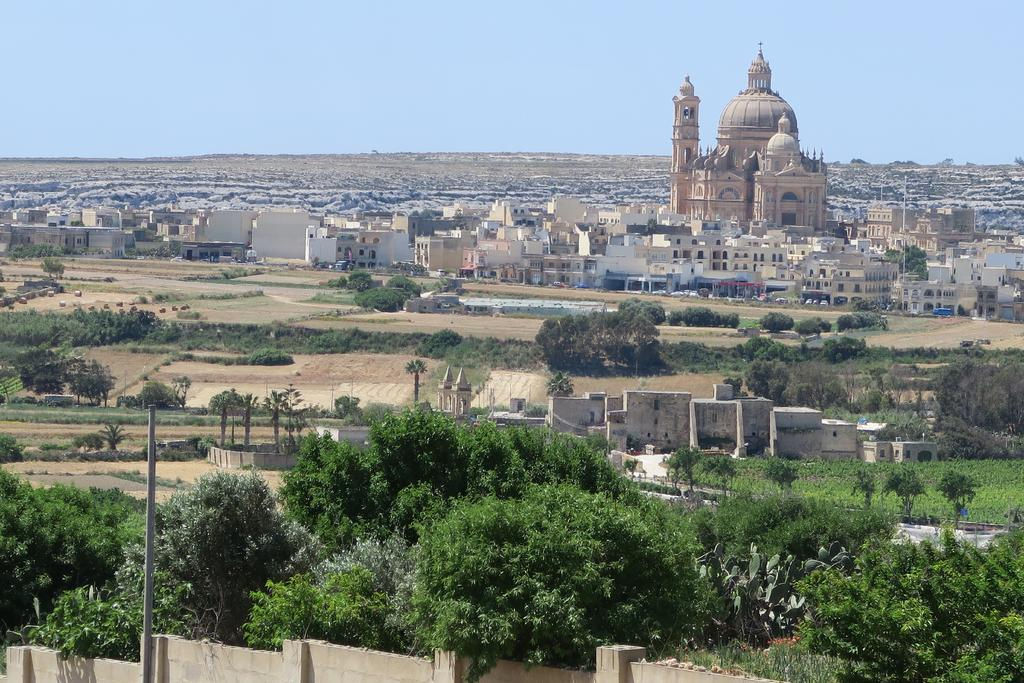What type of structures can be seen in the image? There is a group of buildings and houses in the image. What type of vegetation is present in the image? There is a group of trees, plants, and grass in the image. What other objects can be seen in the image? There is a pole in the image. What is visible in the background of the image? The sky is visible in the image, and it appears cloudy. Can you tell me how many bears are sitting on the roof of the buildings in the image? There are no bears present in the image; it features a group of buildings, trees, plants, grass, a pole, houses, and a cloudy sky. 